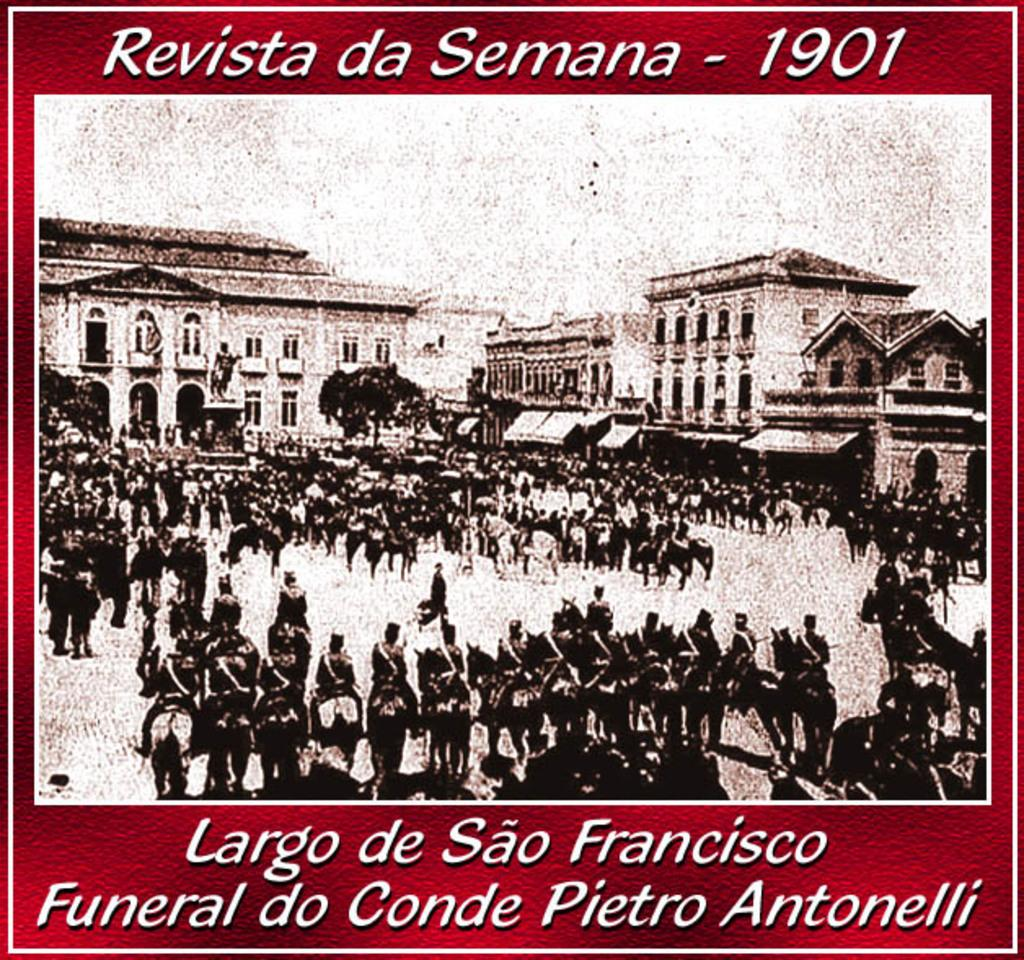<image>
Describe the image concisely. A poster showing a funeral in the Revista da Semana from 1901 